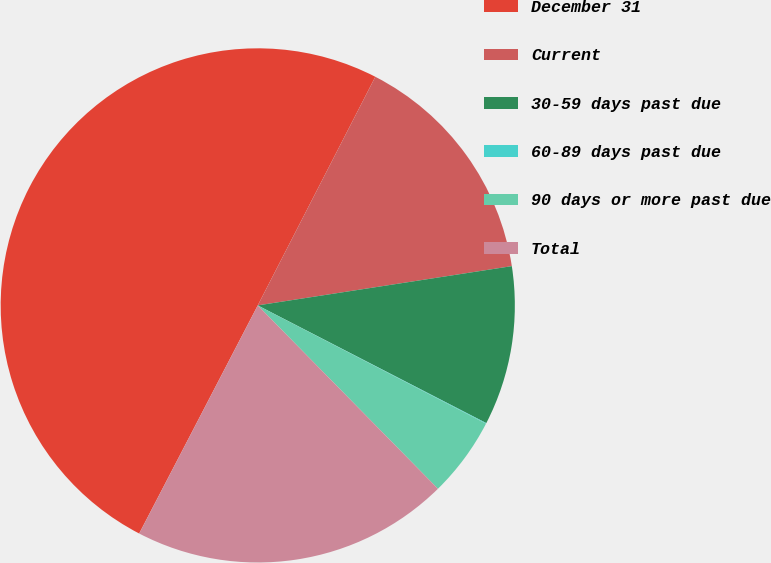Convert chart to OTSL. <chart><loc_0><loc_0><loc_500><loc_500><pie_chart><fcel>December 31<fcel>Current<fcel>30-59 days past due<fcel>60-89 days past due<fcel>90 days or more past due<fcel>Total<nl><fcel>49.93%<fcel>15.0%<fcel>10.01%<fcel>0.04%<fcel>5.03%<fcel>19.99%<nl></chart> 